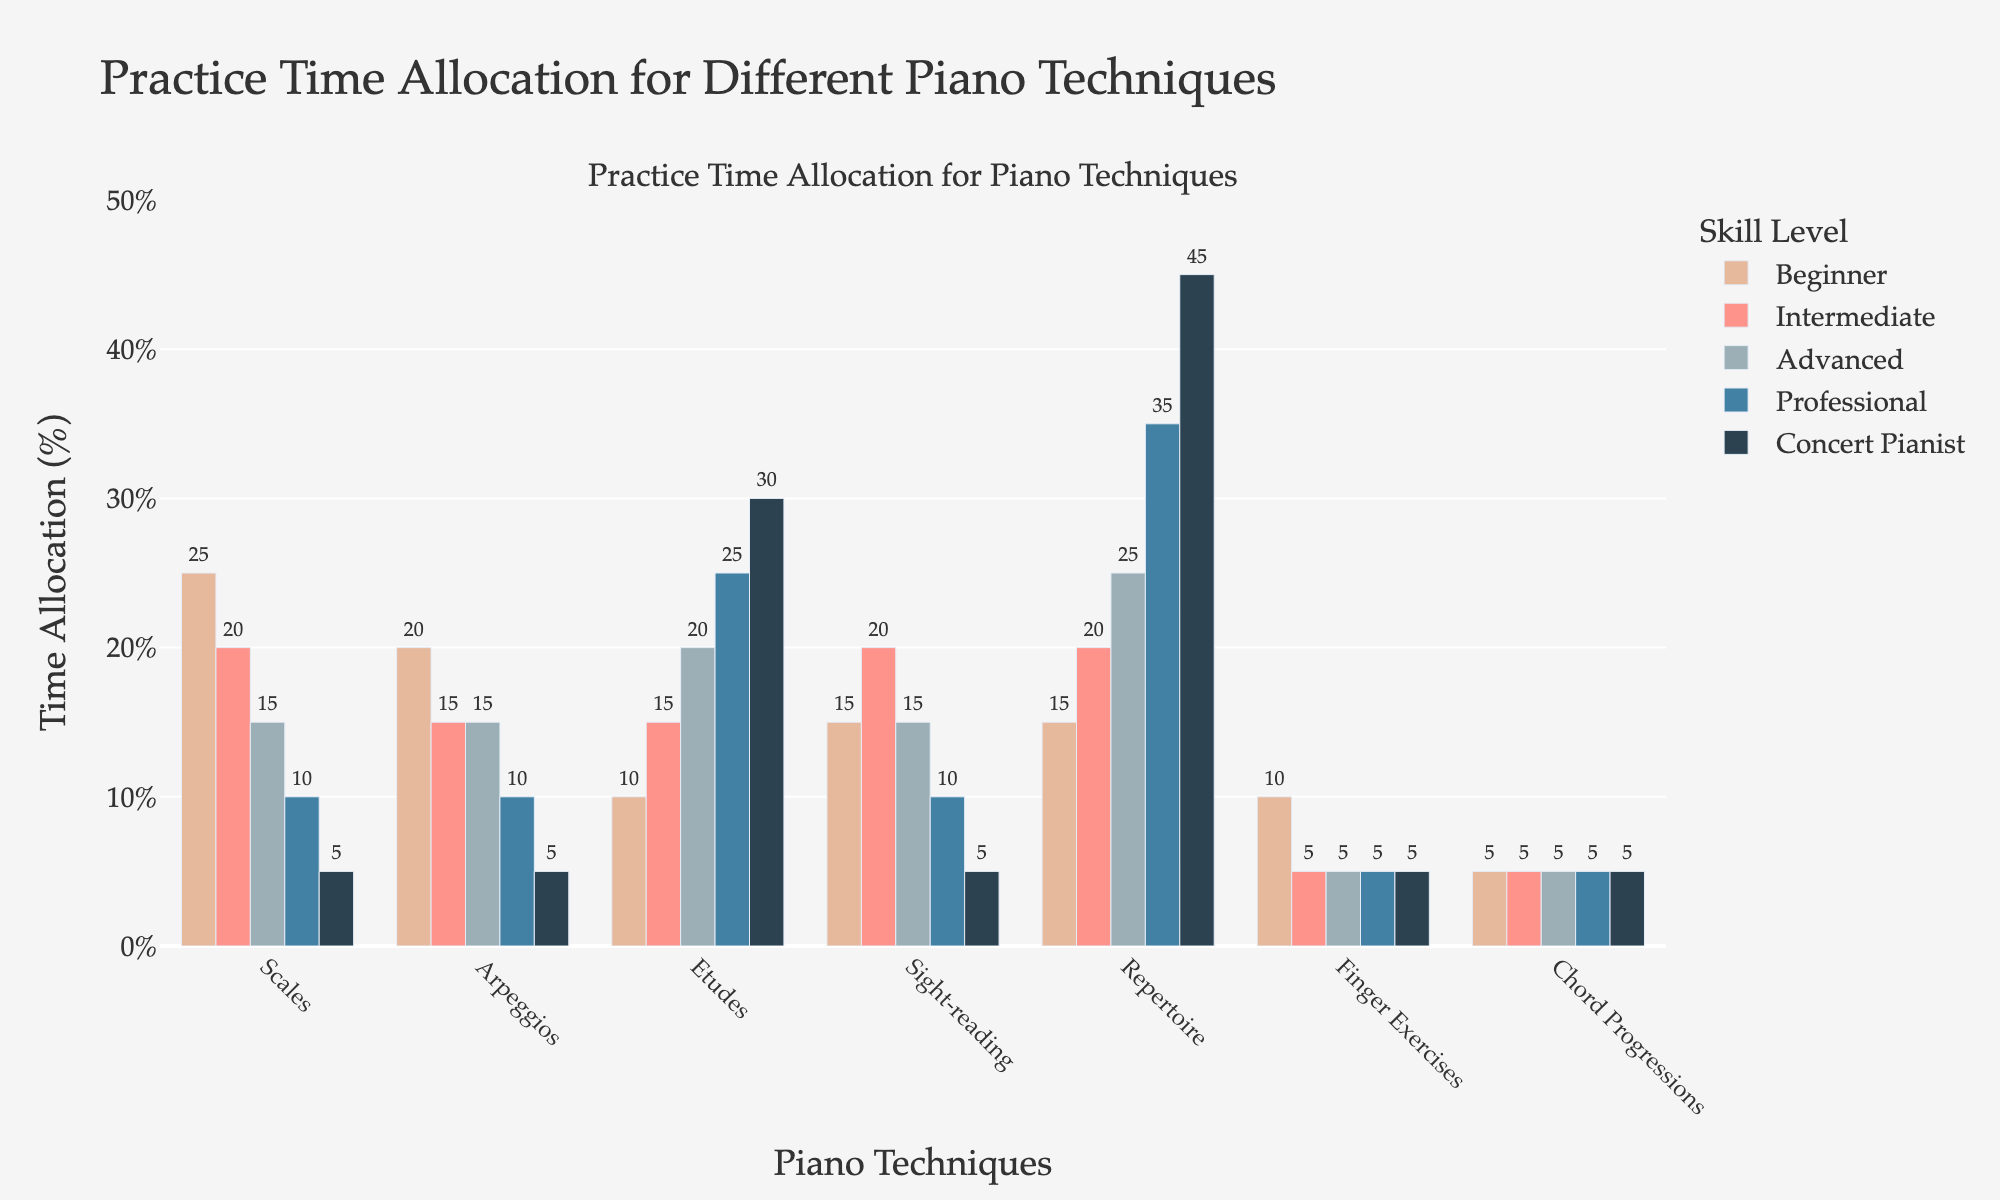what proportion of practice time do professional pianists allocate to scales and arpeggios combined? First, locate the practice time allocated to scales (10%) and arpeggios (10%) for professional pianists. Then, sum the two percentages: 10% + 10% = 20%
Answer: 20% Among concert pianists, which technique receives the least practice time? Look for the smallest value among the practice times for concert pianists. Scales and arpeggios both receive the least amount of practice time at 5% each
Answer: Scales and Arpeggios How does the practice time for arpeggios vary between beginners and advanced pianists? For beginners, the practice time allocated to arpeggios is 20%. For advanced pianists, it is 15%. Subtract the advanced value from the beginner value 20% - 15% = 5%
Answer: Decreases by 5% What is the overall trend in practice time for repertoire as skill level increases from beginner to concert pianist? The practice time shows an increasing trend: Beginner (15%), Intermediate (20%), Advanced (25%), Professional (35%), Concert Pianist (45%)
Answer: Increasing Which skill level allocates more time to etudes than to scales? Identify the skill levels by comparing their practice times for etudes and scales. Both advanced pianists (etudes: 20%, scales: 15%) and higher skill levels show this pattern
Answer: Advanced and higher 